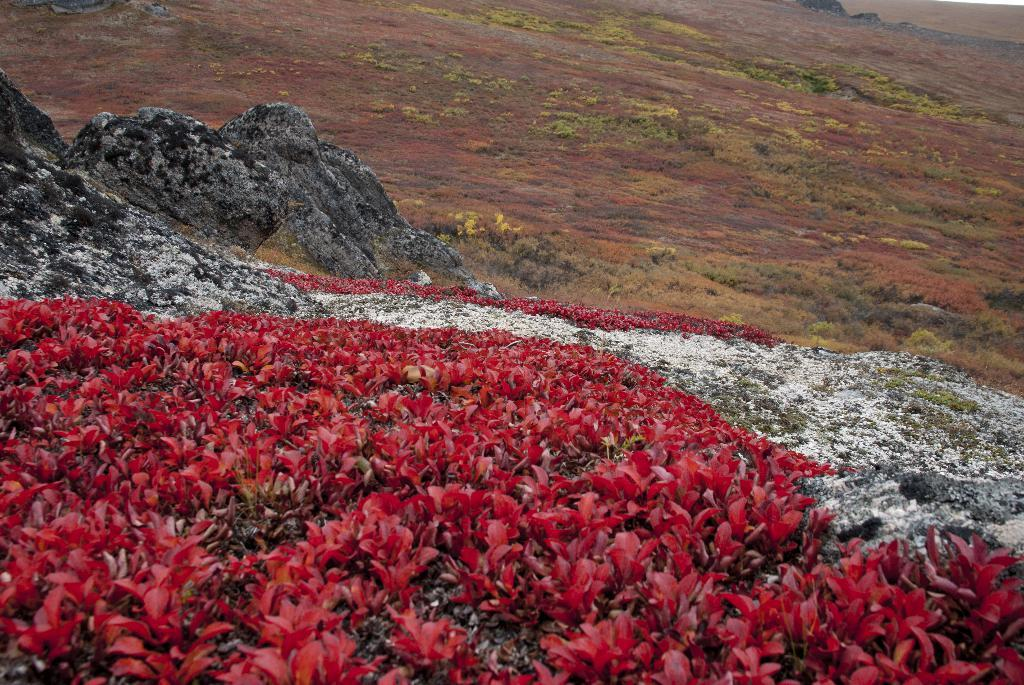What type of vegetation can be seen in the image? There are flowers, plants, and grass in the image. Are there any other natural elements present in the image? Yes, there are rock stones in the image. What type of tub can be seen in the image? There is no tub present in the image. How many bricks are visible in the image? There is no mention of bricks in the provided facts, so it cannot be determined how many, if any, are visible in the image. 